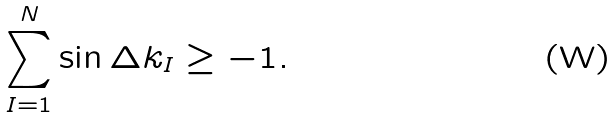<formula> <loc_0><loc_0><loc_500><loc_500>\sum _ { I = 1 } ^ { N } \sin \Delta k _ { I } \geq - 1 .</formula> 